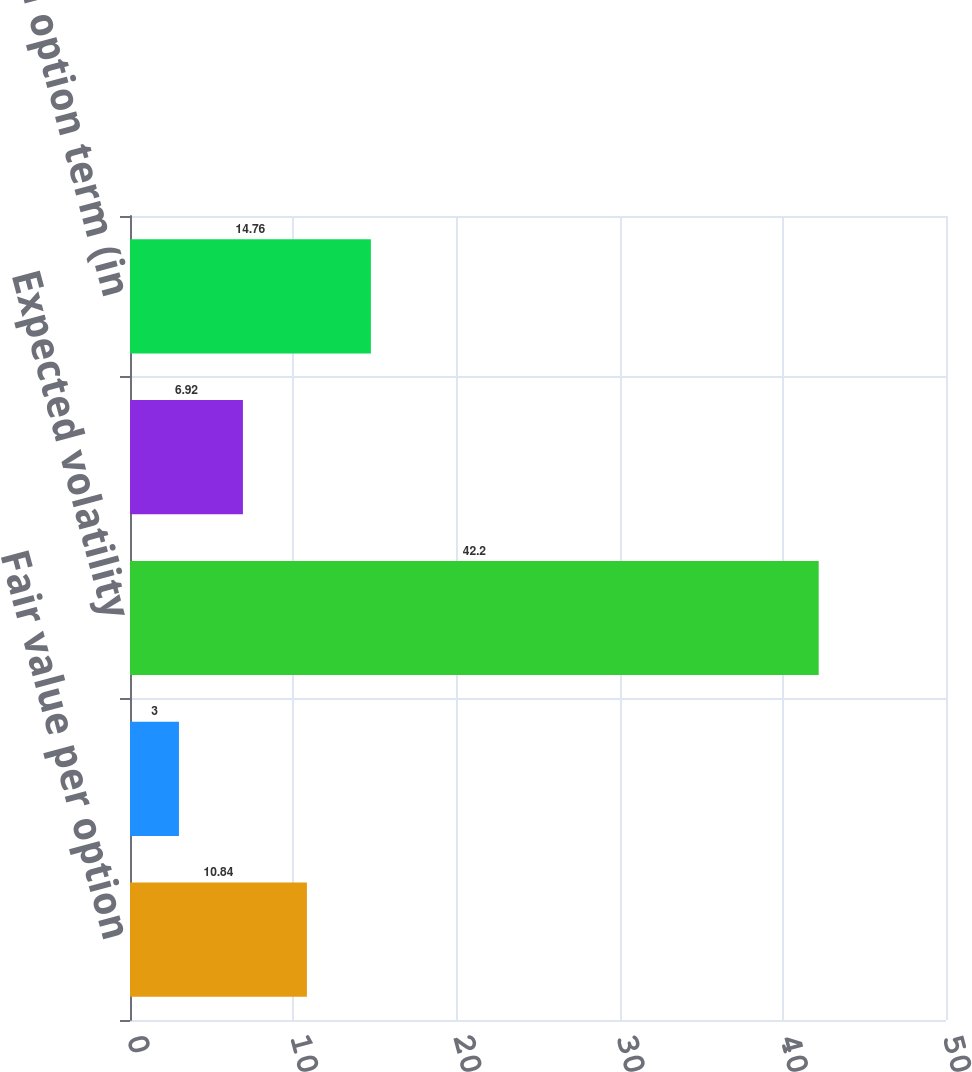Convert chart to OTSL. <chart><loc_0><loc_0><loc_500><loc_500><bar_chart><fcel>Fair value per option<fcel>Annualized dividend yield<fcel>Expected volatility<fcel>Risk-free interest rate<fcel>Expected option term (in<nl><fcel>10.84<fcel>3<fcel>42.2<fcel>6.92<fcel>14.76<nl></chart> 